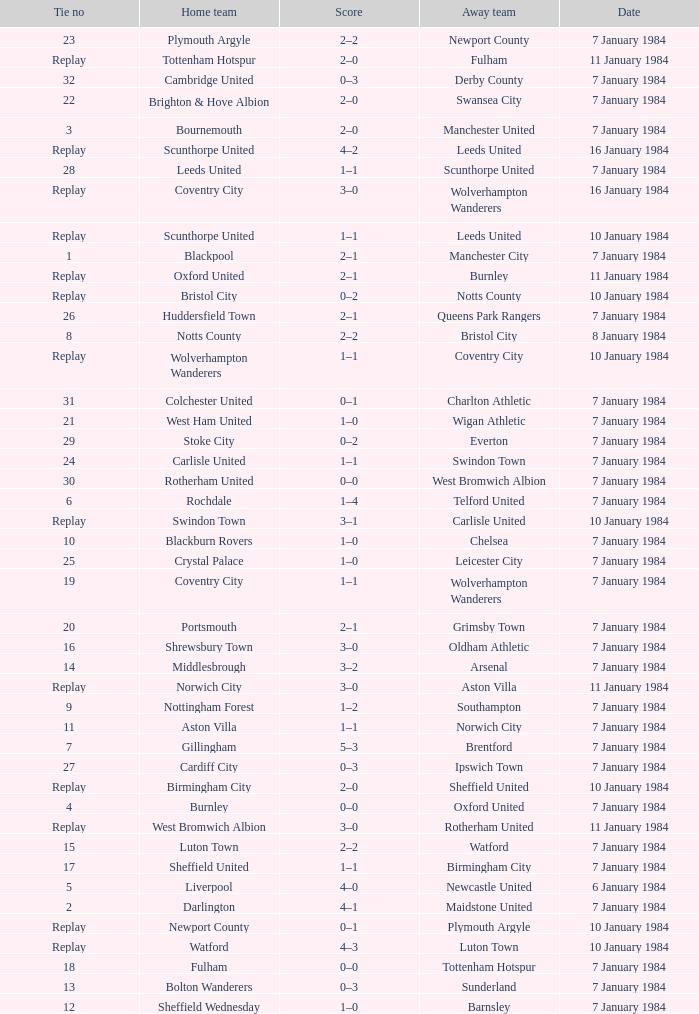Write the full table. {'header': ['Tie no', 'Home team', 'Score', 'Away team', 'Date'], 'rows': [['23', 'Plymouth Argyle', '2–2', 'Newport County', '7 January 1984'], ['Replay', 'Tottenham Hotspur', '2–0', 'Fulham', '11 January 1984'], ['32', 'Cambridge United', '0–3', 'Derby County', '7 January 1984'], ['22', 'Brighton & Hove Albion', '2–0', 'Swansea City', '7 January 1984'], ['3', 'Bournemouth', '2–0', 'Manchester United', '7 January 1984'], ['Replay', 'Scunthorpe United', '4–2', 'Leeds United', '16 January 1984'], ['28', 'Leeds United', '1–1', 'Scunthorpe United', '7 January 1984'], ['Replay', 'Coventry City', '3–0', 'Wolverhampton Wanderers', '16 January 1984'], ['Replay', 'Scunthorpe United', '1–1', 'Leeds United', '10 January 1984'], ['1', 'Blackpool', '2–1', 'Manchester City', '7 January 1984'], ['Replay', 'Oxford United', '2–1', 'Burnley', '11 January 1984'], ['Replay', 'Bristol City', '0–2', 'Notts County', '10 January 1984'], ['26', 'Huddersfield Town', '2–1', 'Queens Park Rangers', '7 January 1984'], ['8', 'Notts County', '2–2', 'Bristol City', '8 January 1984'], ['Replay', 'Wolverhampton Wanderers', '1–1', 'Coventry City', '10 January 1984'], ['31', 'Colchester United', '0–1', 'Charlton Athletic', '7 January 1984'], ['21', 'West Ham United', '1–0', 'Wigan Athletic', '7 January 1984'], ['29', 'Stoke City', '0–2', 'Everton', '7 January 1984'], ['24', 'Carlisle United', '1–1', 'Swindon Town', '7 January 1984'], ['30', 'Rotherham United', '0–0', 'West Bromwich Albion', '7 January 1984'], ['6', 'Rochdale', '1–4', 'Telford United', '7 January 1984'], ['Replay', 'Swindon Town', '3–1', 'Carlisle United', '10 January 1984'], ['10', 'Blackburn Rovers', '1–0', 'Chelsea', '7 January 1984'], ['25', 'Crystal Palace', '1–0', 'Leicester City', '7 January 1984'], ['19', 'Coventry City', '1–1', 'Wolverhampton Wanderers', '7 January 1984'], ['20', 'Portsmouth', '2–1', 'Grimsby Town', '7 January 1984'], ['16', 'Shrewsbury Town', '3–0', 'Oldham Athletic', '7 January 1984'], ['14', 'Middlesbrough', '3–2', 'Arsenal', '7 January 1984'], ['Replay', 'Norwich City', '3–0', 'Aston Villa', '11 January 1984'], ['9', 'Nottingham Forest', '1–2', 'Southampton', '7 January 1984'], ['11', 'Aston Villa', '1–1', 'Norwich City', '7 January 1984'], ['7', 'Gillingham', '5–3', 'Brentford', '7 January 1984'], ['27', 'Cardiff City', '0–3', 'Ipswich Town', '7 January 1984'], ['Replay', 'Birmingham City', '2–0', 'Sheffield United', '10 January 1984'], ['4', 'Burnley', '0–0', 'Oxford United', '7 January 1984'], ['Replay', 'West Bromwich Albion', '3–0', 'Rotherham United', '11 January 1984'], ['15', 'Luton Town', '2–2', 'Watford', '7 January 1984'], ['17', 'Sheffield United', '1–1', 'Birmingham City', '7 January 1984'], ['5', 'Liverpool', '4–0', 'Newcastle United', '6 January 1984'], ['2', 'Darlington', '4–1', 'Maidstone United', '7 January 1984'], ['Replay', 'Newport County', '0–1', 'Plymouth Argyle', '10 January 1984'], ['Replay', 'Watford', '4–3', 'Luton Town', '10 January 1984'], ['18', 'Fulham', '0–0', 'Tottenham Hotspur', '7 January 1984'], ['13', 'Bolton Wanderers', '0–3', 'Sunderland', '7 January 1984'], ['12', 'Sheffield Wednesday', '1–0', 'Barnsley', '7 January 1984']]} Who was the away team against the home team Sheffield United? Birmingham City. 